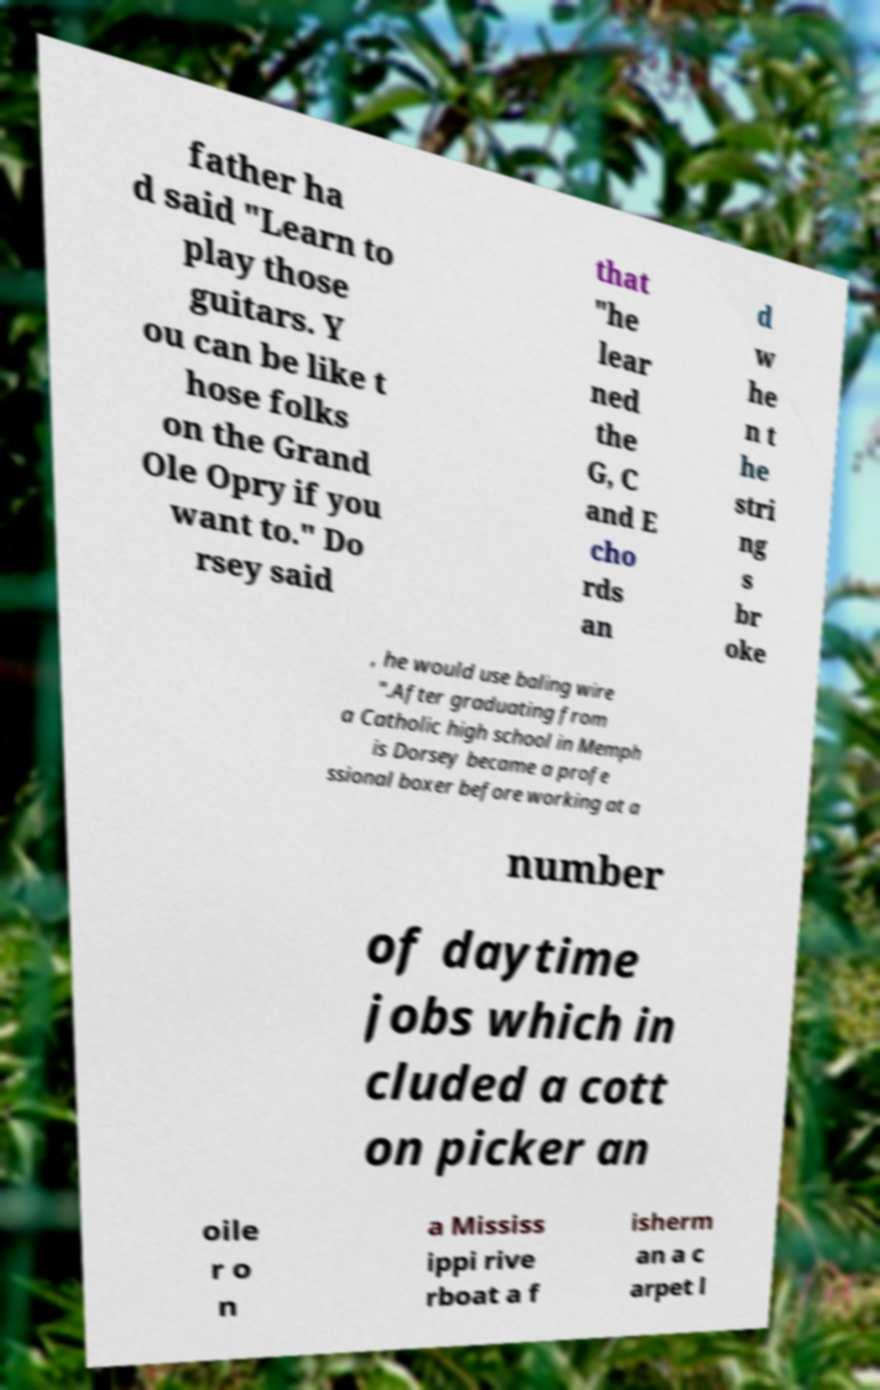Could you extract and type out the text from this image? father ha d said "Learn to play those guitars. Y ou can be like t hose folks on the Grand Ole Opry if you want to." Do rsey said that "he lear ned the G, C and E cho rds an d w he n t he stri ng s br oke , he would use baling wire ".After graduating from a Catholic high school in Memph is Dorsey became a profe ssional boxer before working at a number of daytime jobs which in cluded a cott on picker an oile r o n a Mississ ippi rive rboat a f isherm an a c arpet l 